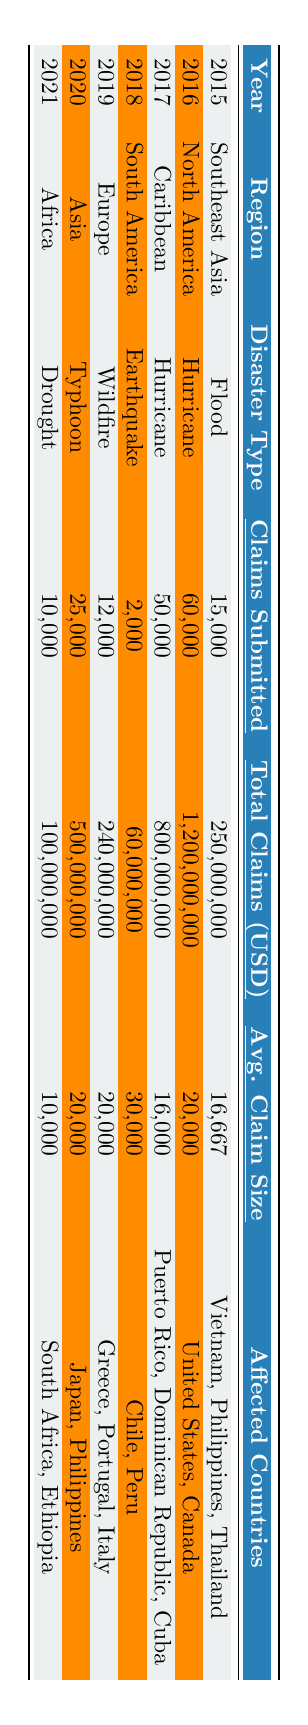What is the total amount of claims submitted in 2016? The table shows that in 2016, the total claims submitted in North America for Hurricane disasters was 60,000.
Answer: 60,000 Which region had the highest average claim size in 2018? In 2018, the average claim size for the South America region was 30,000, which is higher than any other year listed.
Answer: South America How many claims were submitted for disasters in the Caribbean in 2017? The table indicates that 50,000 claims were submitted in the Caribbean region in 2017 due to Hurricane disasters.
Answer: 50,000 In which year did Southeast Asia experience flood claims and what was the total claims amount? The table shows that Southeast Asia experienced flood claims in 2015, with a total claims amount of 250,000,000 USD.
Answer: 2015, 250,000,000 USD What was the average claim size for the floods in Asia in 2020? In 2020, the average claim size for Typhoon disasters in Asia was 20,000 according to the table.
Answer: 20,000 Which disaster type had the fewest claims submitted between 2015 and 2021? According to the table, the earthquake in South America in 2018 had the fewest claims submitted, totaling 2,000.
Answer: Earthquake What was the difference in the total claims amount between North America in 2016 and Africa in 2021? In 2016, North America had total claims of 1,200,000,000 USD, while Africa in 2021 had total claims of 100,000,000 USD. The difference is 1,200,000,000 - 100,000,000 = 1,100,000,000 USD.
Answer: 1,100,000,000 USD How many affected countries were there in total for natural disasters from 2015 to 2021? From the table, count the unique affected countries: Vietnam, Philippines, Thailand, United States, Canada, Puerto Rico, Dominican Republic, Cuba, Chile, Peru, Greece, Portugal, Italy, Japan, South Africa, and Ethiopia. This totals to 15 unique countries.
Answer: 15 Which year had the highest number of claims submitted for a single disaster type? The highest number of claims submitted was in 2016 with 60,000 claims for Hurricane disasters in North America.
Answer: 2016 Did the average claim size increase from 2015 to 2021? Analyze the average claim sizes: in 2015 it was 16,667, in 2016 was 20,000, in 2017 was 16,000, in 2018 was 30,000, in 2019 was 20,000, in 2020 was 20,000, and in 2021 was 10,000. The average claim size was not consistently increasing.
Answer: No What is the total number of claims submitted across all regions in 2019 and 2020? The table shows that in 2019 there were 12,000 claims and in 2020 there were 25,000 claims. The total is 12,000 + 25,000 = 37,000 claims.
Answer: 37,000 